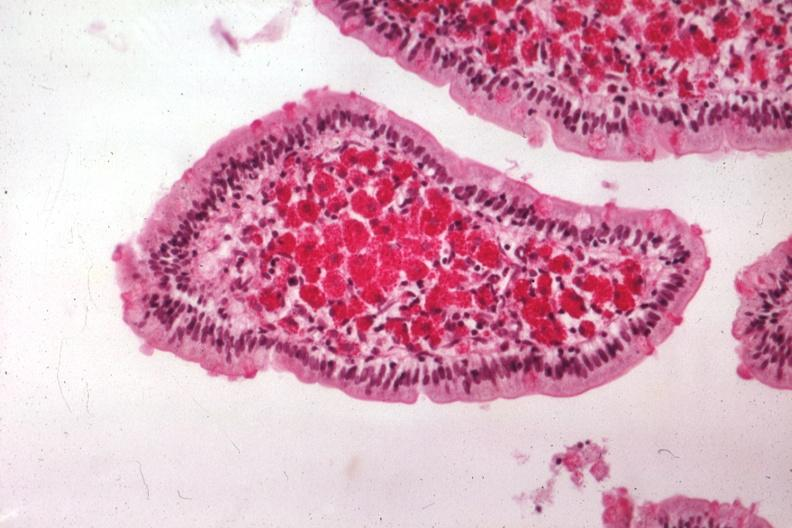what is present?
Answer the question using a single word or phrase. Whipples disease 